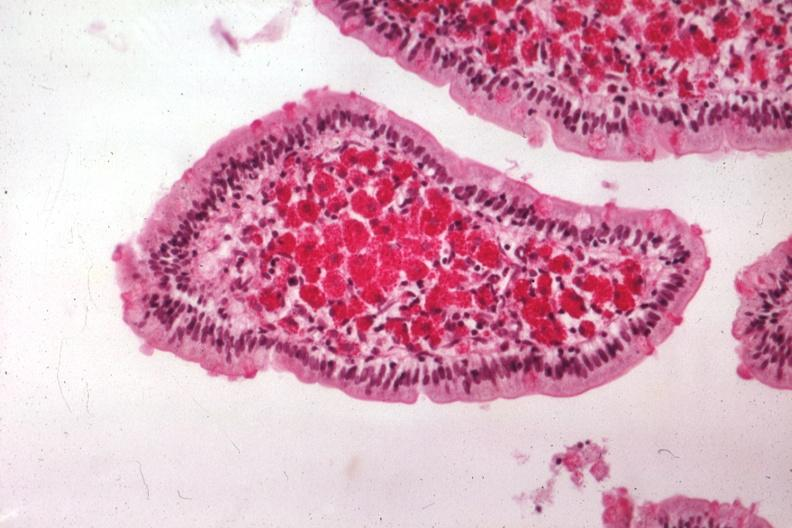what is present?
Answer the question using a single word or phrase. Whipples disease 